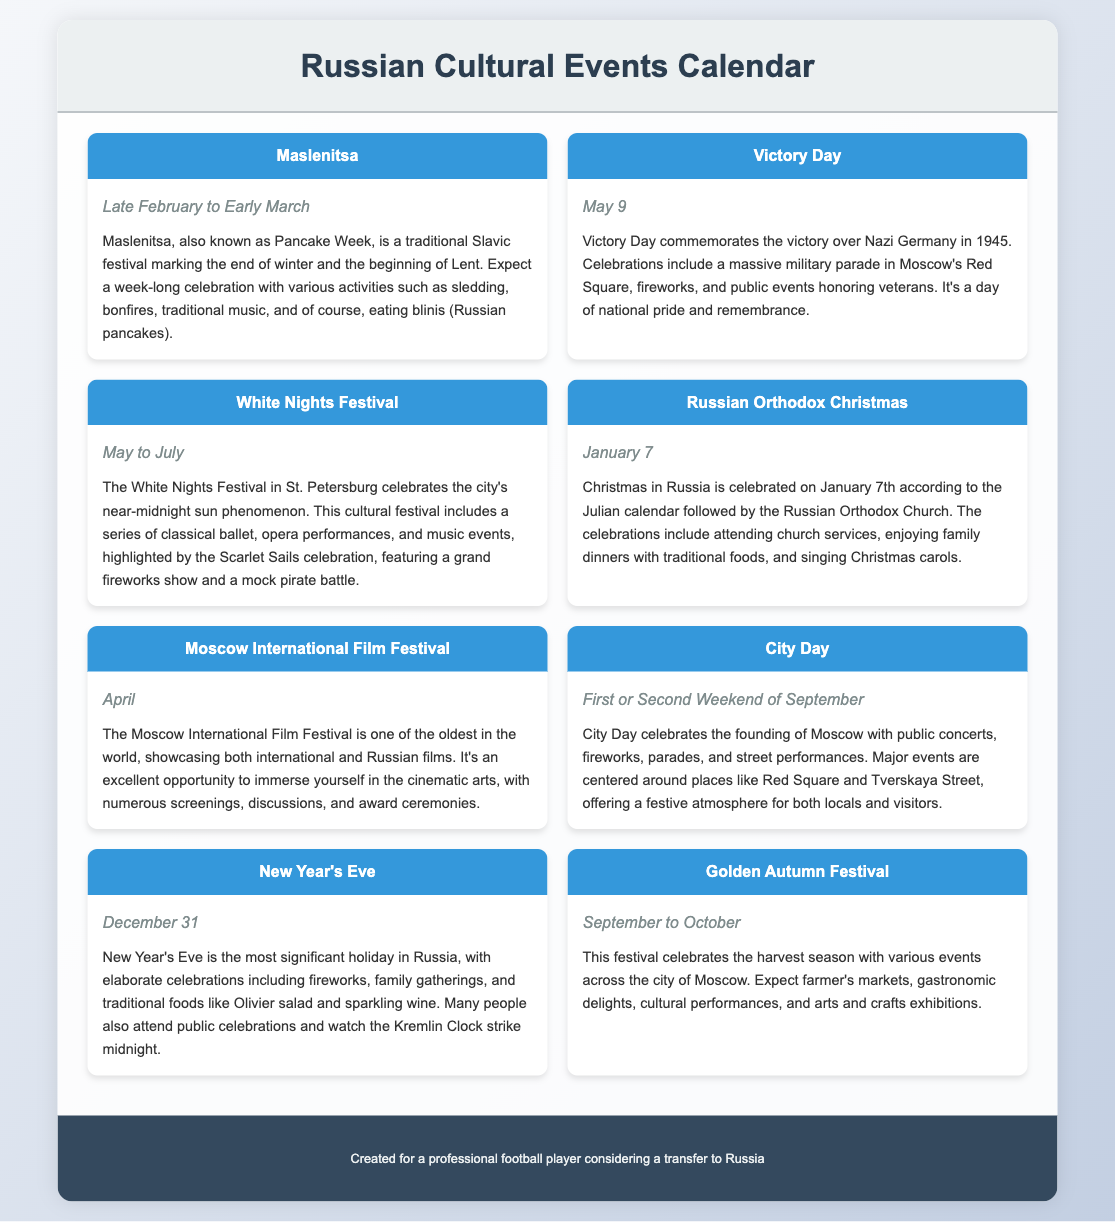What is the date of Victory Day? Victory Day is celebrated on May 9, as mentioned in the event description.
Answer: May 9 When does the White Nights Festival take place? The White Nights Festival occurs from May to July, according to the calendar details.
Answer: May to July What traditional food is associated with Maslenitsa? The event description states that blinis (Russian pancakes) are a traditional food for the festival.
Answer: Blinis What significant holiday is celebrated on December 31? The document indicates that New Year's Eve is the most significant holiday in Russia.
Answer: New Year's Eve What festival marks the end of winter and the beginning of Lent? The festival described at the beginning of the document is Maslenitsa, which correlates with this description.
Answer: Maslenitsa What event includes a military parade in Moscow? According to the document, Victory Day includes a massive military parade in Red Square.
Answer: Victory Day In which month does the Moscow International Film Festival occur? The document specifies that the Moscow International Film Festival takes place in April.
Answer: April What type of events are featured in the Golden Autumn Festival? The festival features farmer's markets, gastronomic delights, and cultural performances as highlighted in the event description.
Answer: Harvest celebrations What time of year is Russian Orthodox Christmas celebrated? The calendar states that Russian Orthodox Christmas is celebrated on January 7.
Answer: January 7 